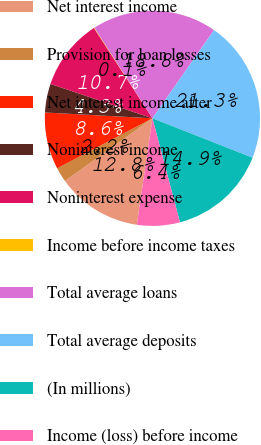<chart> <loc_0><loc_0><loc_500><loc_500><pie_chart><fcel>Net interest income<fcel>Provision for loan losses<fcel>Net interest income after<fcel>Noninterest income<fcel>Noninterest expense<fcel>Income before income taxes<fcel>Total average loans<fcel>Total average deposits<fcel>(In millions)<fcel>Income (loss) before income<nl><fcel>12.79%<fcel>2.2%<fcel>8.55%<fcel>4.32%<fcel>10.67%<fcel>0.08%<fcel>18.77%<fcel>21.26%<fcel>14.91%<fcel>6.44%<nl></chart> 